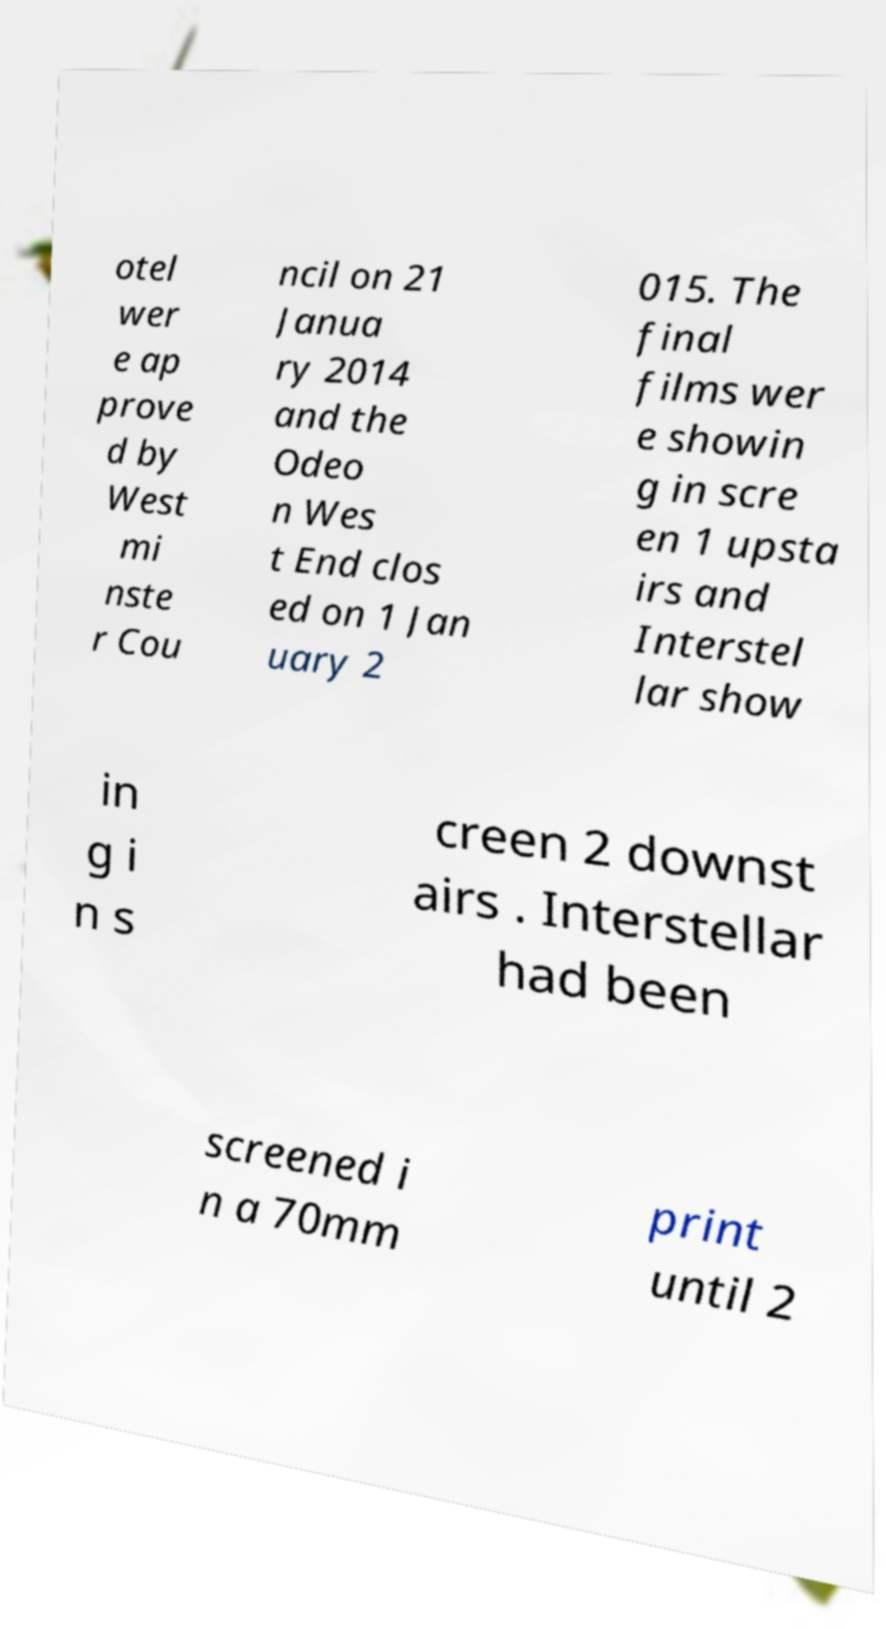Please identify and transcribe the text found in this image. otel wer e ap prove d by West mi nste r Cou ncil on 21 Janua ry 2014 and the Odeo n Wes t End clos ed on 1 Jan uary 2 015. The final films wer e showin g in scre en 1 upsta irs and Interstel lar show in g i n s creen 2 downst airs . Interstellar had been screened i n a 70mm print until 2 